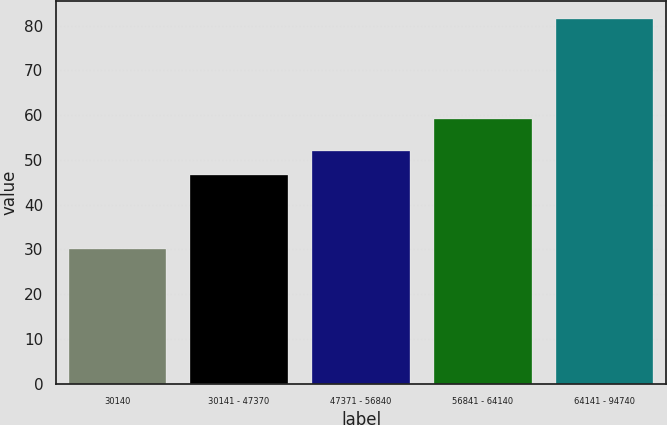Convert chart to OTSL. <chart><loc_0><loc_0><loc_500><loc_500><bar_chart><fcel>30140<fcel>30141 - 47370<fcel>47371 - 56840<fcel>56841 - 64140<fcel>64141 - 94740<nl><fcel>30.14<fcel>46.53<fcel>51.96<fcel>59.11<fcel>81.48<nl></chart> 